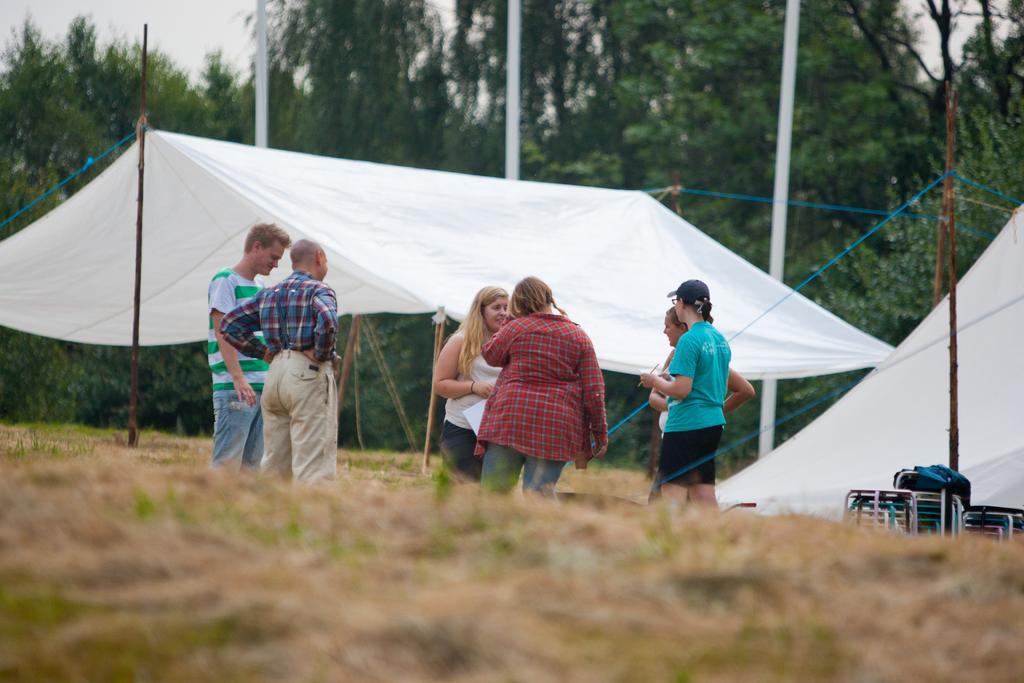Could you give a brief overview of what you see in this image? This is an outside view. At the bottom, I can see the ground. In the middle of the image few people are standing. Behind these people there are two tents. On the right side there are few luggage bags. In the background, I can see few poles and trees. At the top of the image I can see the sky. 